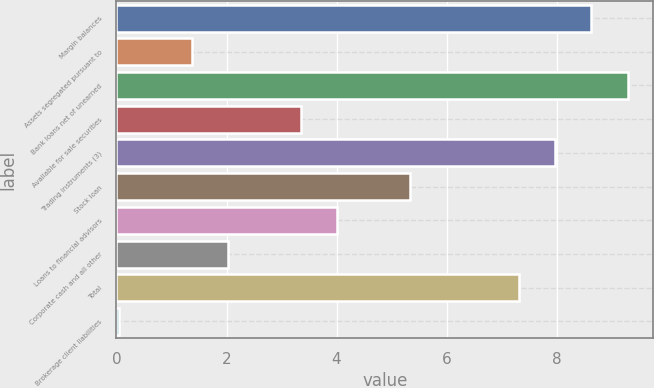Convert chart. <chart><loc_0><loc_0><loc_500><loc_500><bar_chart><fcel>Margin balances<fcel>Assets segregated pursuant to<fcel>Bank loans net of unearned<fcel>Available for sale securities<fcel>Trading instruments (3)<fcel>Stock loan<fcel>Loans to financial advisors<fcel>Corporate cash and all other<fcel>Total<fcel>Brokerage client liabilities<nl><fcel>8.63<fcel>1.37<fcel>9.29<fcel>3.35<fcel>7.97<fcel>5.33<fcel>4.01<fcel>2.03<fcel>7.31<fcel>0.05<nl></chart> 